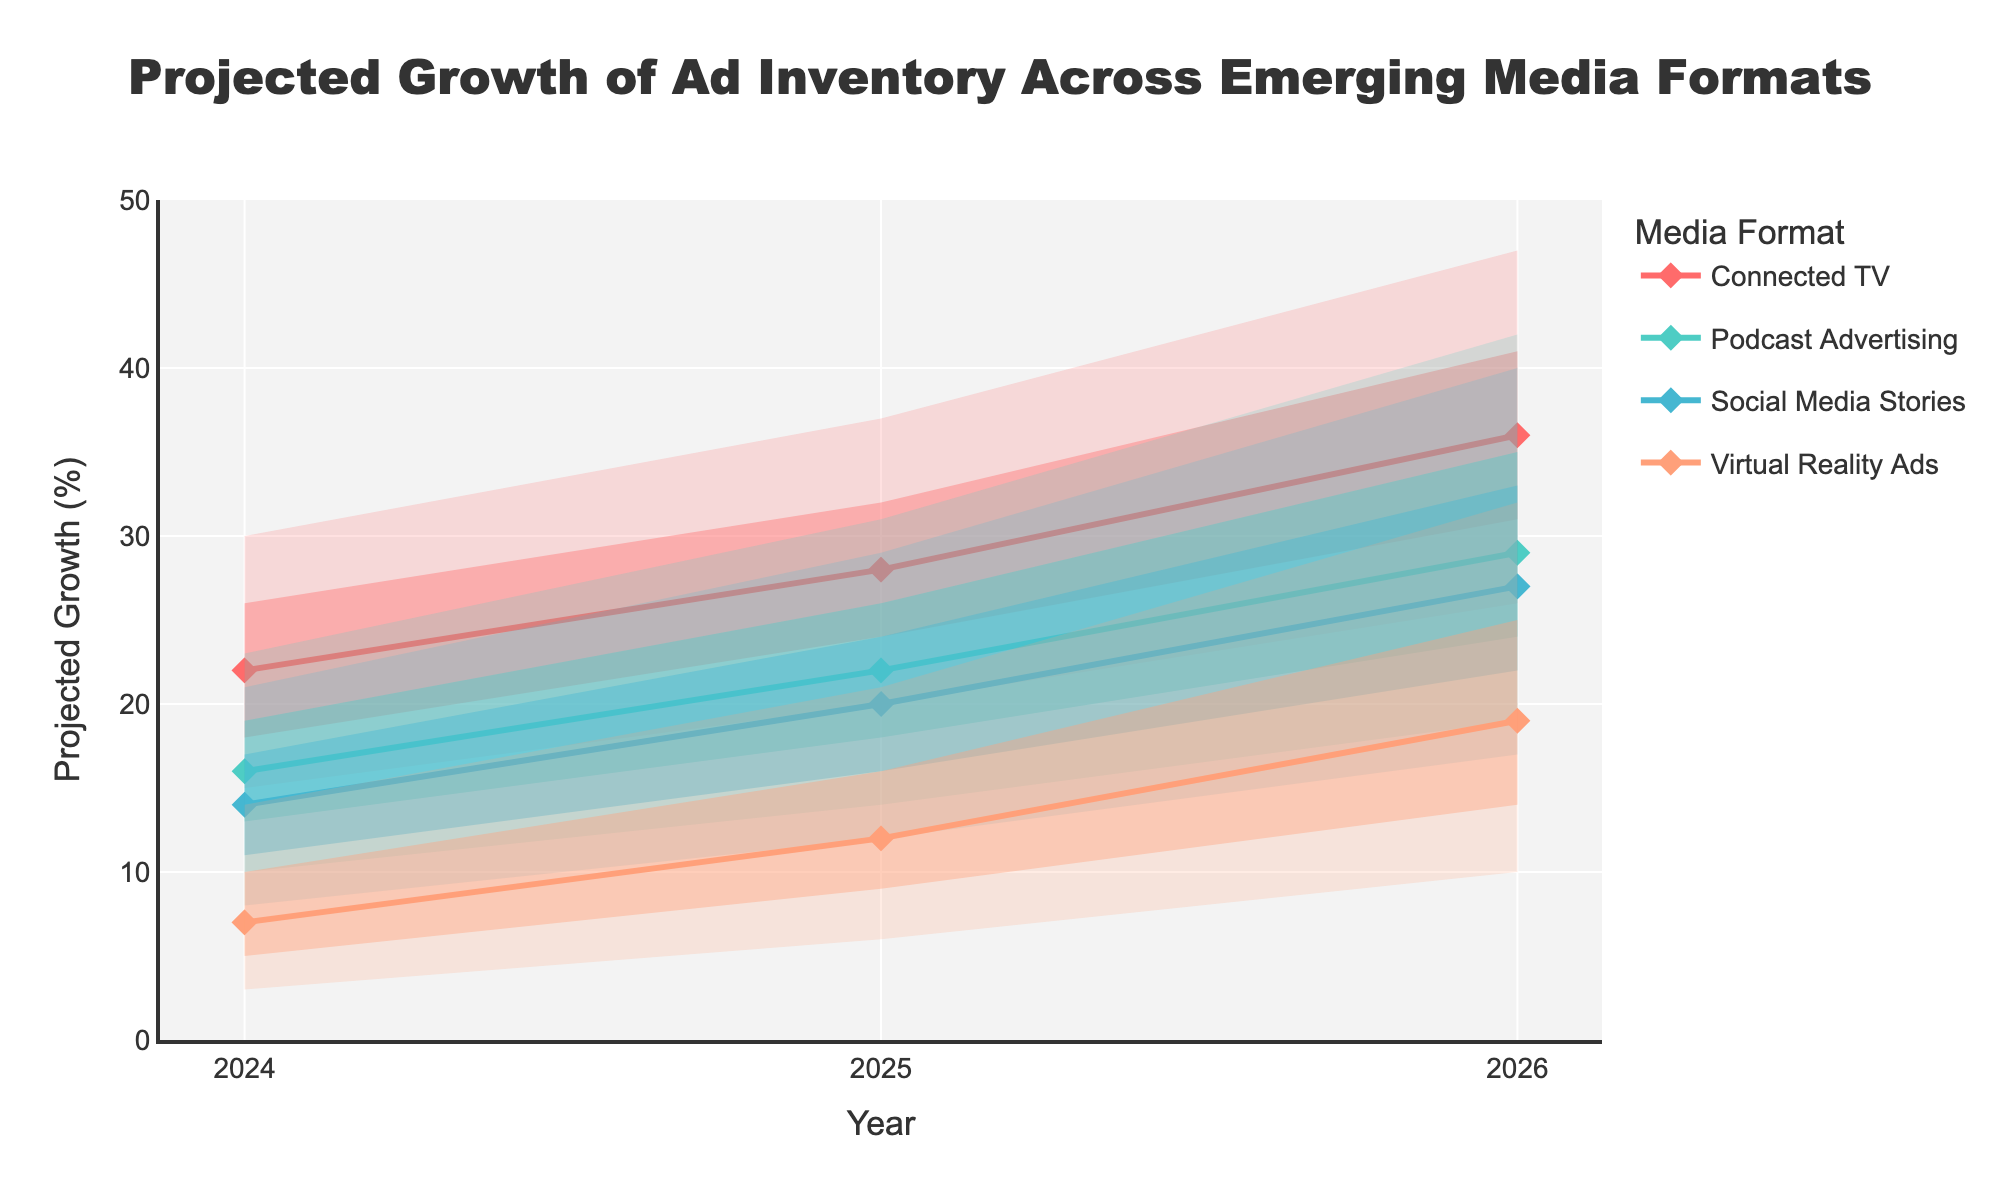What's the title of the figure? The title is displayed at the top center of the figure in a large font. It is "Projected Growth of Ad Inventory Across Emerging Media Formats".
Answer: Projected Growth of Ad Inventory Across Emerging Media Formats What years are covered in the figure? The x-axis of the figure shows the years covered. They are 2024, 2025, and 2026.
Answer: 2024, 2025, 2026 Which media format shows the highest projected growth in 2026 according to the "High" projection? By looking at the "High" projections for 2026, the highest value is for "Connected TV" which is 47%.
Answer: Connected TV What is the range of projected growth for Podcast Advertising in 2025? The range of projected growth can be found by looking at the "Low" and "High" values for Podcast Advertising in 2025, which are 14% and 31%, respectively.
Answer: 14% to 31% Which media format has the lowest "Mid" projection in 2024? By looking at the "Mid" projections for each media format in 2024, the lowest value is for "Virtual Reality Ads" which is 7%.
Answer: Virtual Reality Ads How do the "Mid" projections for Social Media Stories change from 2024 to 2026? To find the change, look at the "Mid" projections for Social Media Stories in 2024 and 2026, which are 14% and 27%, respectively. The change is 27% - 14% = 13%.
Answer: 13% Which media format shows the largest increase in the "Low" projection from 2024 to 2026? By looking at the "Low" projections for each format in 2024 and 2026 and calculating the differences, "Virtual Reality Ads" shows the largest increase (10 - 3 = 7).
Answer: Virtual Reality Ads What is the difference between the "High" and "Low" projections for Connected TV in 2025? The "High" projection for Connected TV in 2025 is 37% and the "Low" projection is 20%. The difference is 37% - 20% = 17%.
Answer: 17% Which media format shows the most variability in its projections for 2024? Variability can be determined by the width of the fan chart for each format. In 2024, "Virtual Reality Ads" has the largest range from 3% to 14%.
Answer: Virtual Reality Ads 